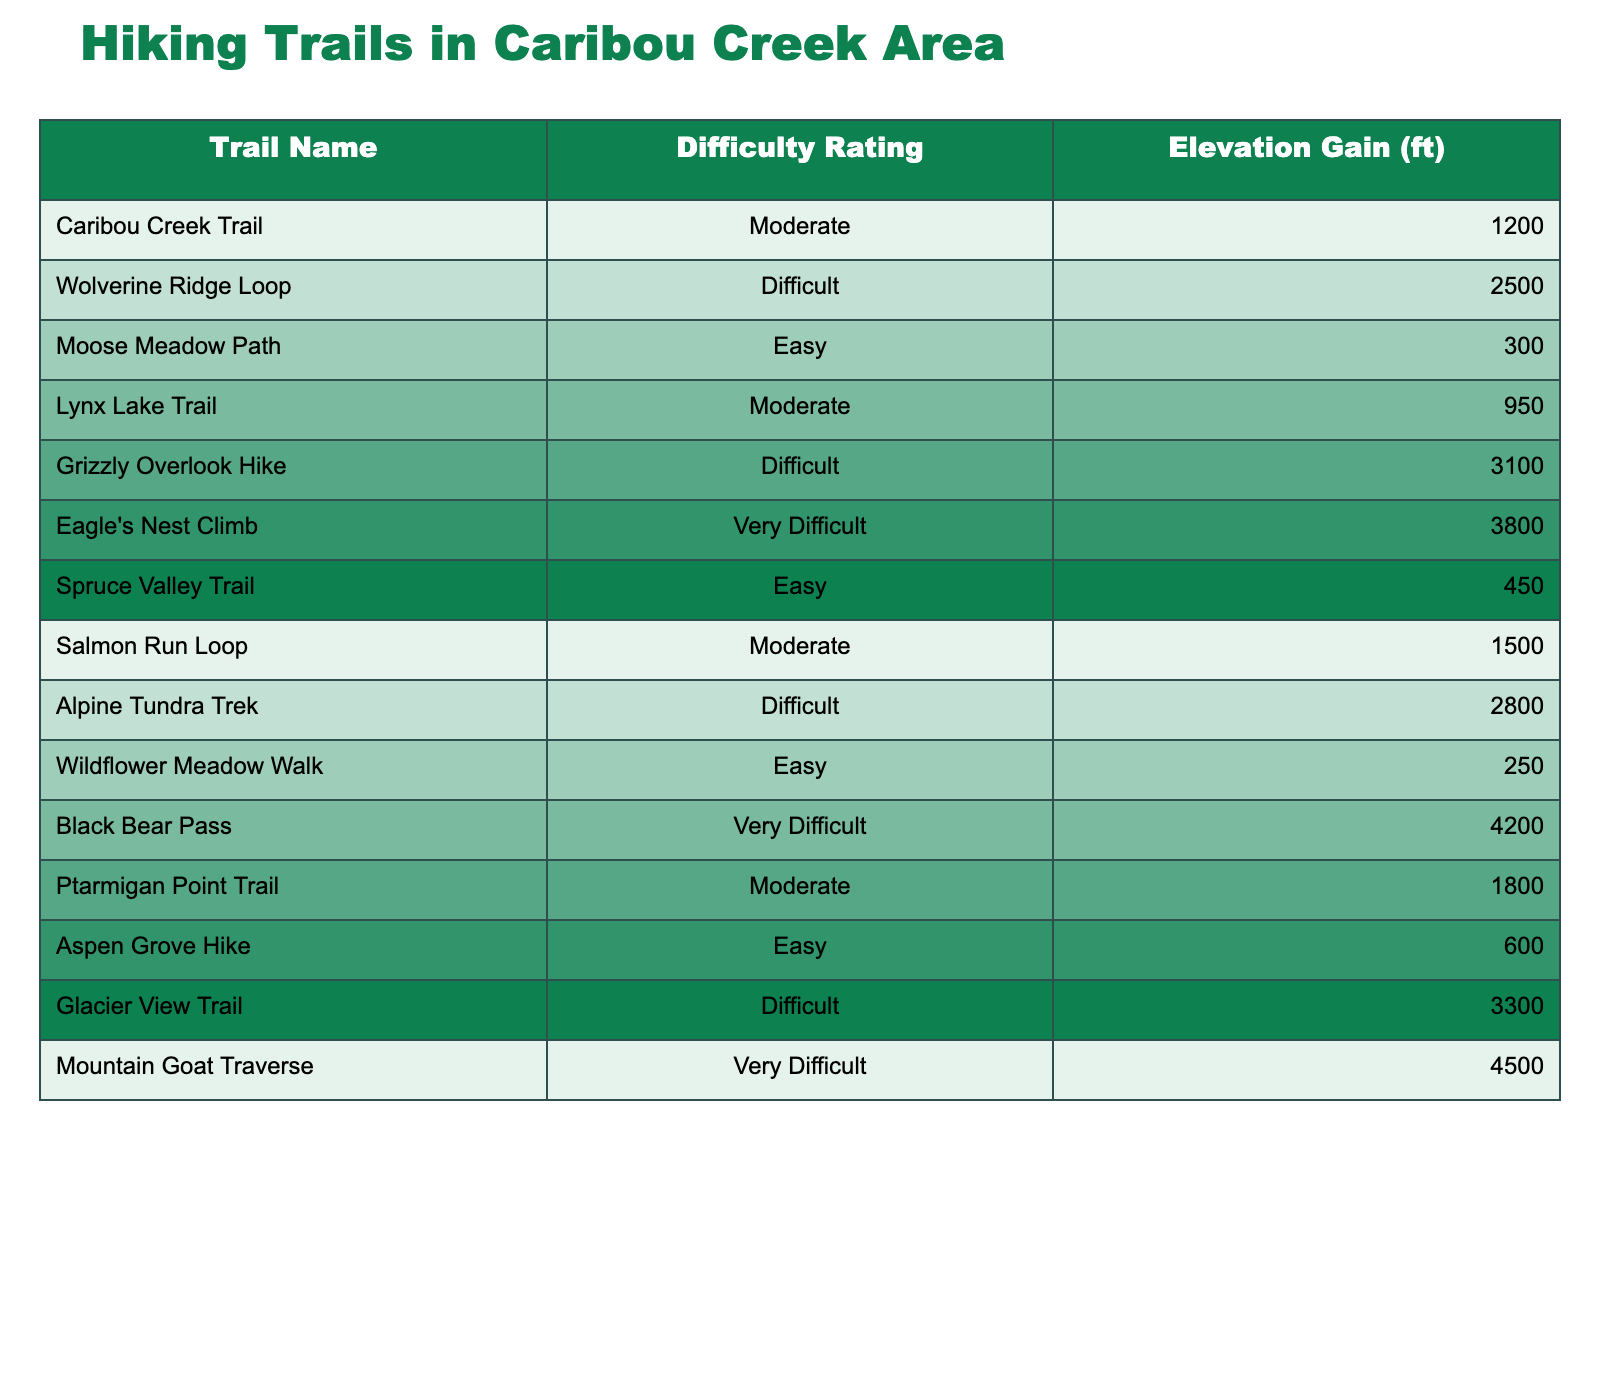What is the highest elevation gain among the trails? The table lists the elevation gains for each trail. The highest value is for the "Mountain Goat Traverse" at 4500 ft.
Answer: 4500 ft How many trails are rated as "Difficult"? By reviewing the difficulty ratings in the table, there are 4 trails categorized as "Difficult." These are Wolverine Ridge Loop, Grizzly Overlook Hike, Alpine Tundra Trek, and Glacier View Trail.
Answer: 4 What is the elevation gain of the "Lynx Lake Trail"? The table states that the elevation gain for the "Lynx Lake Trail" is 950 ft.
Answer: 950 ft Which trail has the lowest elevation gain? Looking at the elevation gains provided, "Moose Meadow Path" has the lowest elevation gain of 300 ft.
Answer: 300 ft What is the average elevation gain for trails rated "Easy"? The elevation gains for the "Easy" rated trails are 300 ft, 450 ft, 250 ft, and 600 ft. Adding these gives 300 + 450 + 250 + 600 = 1600 ft. Dividing by 4 (the number of "Easy" trails) gives an average of 400 ft.
Answer: 400 ft Are there any trails with a "Very Difficult" rating? The table indicates there are two trails with a "Very Difficult" rating: Black Bear Pass and Mountain Goat Traverse.
Answer: Yes What is the total elevation gain for all trails rated "Moderate"? The elevation gains for the "Moderate" trails are 1200 ft, 950 ft, 1500 ft, and 1800 ft. Summing these gives 1200 + 950 + 1500 + 1800 = 4450 ft.
Answer: 4450 ft How does the elevation gain of "Salmon Run Loop" compare to "Moose Meadow Path"? "Salmon Run Loop" has an elevation gain of 1500 ft, while "Moose Meadow Path" has 300 ft. Therefore, "Salmon Run Loop" has significantly higher elevation gain.
Answer: Higher Which trail has the second highest elevation gain? The second highest elevation gain is associated with the "Grizzly Overlook Hike," which has an elevation gain of 3100 ft, following the "Mountain Goat Traverse."
Answer: 3100 ft Is the "Eagle's Nest Climb" rated as "Difficult" or "Very Difficult"? Based on the table, the "Eagle's Nest Climb" is classified as "Very Difficult."
Answer: Very Difficult 